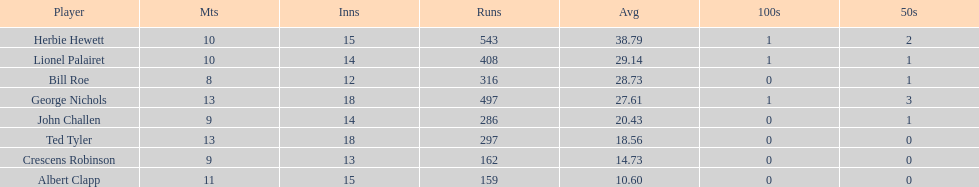Which player had the least amount of runs? Albert Clapp. 